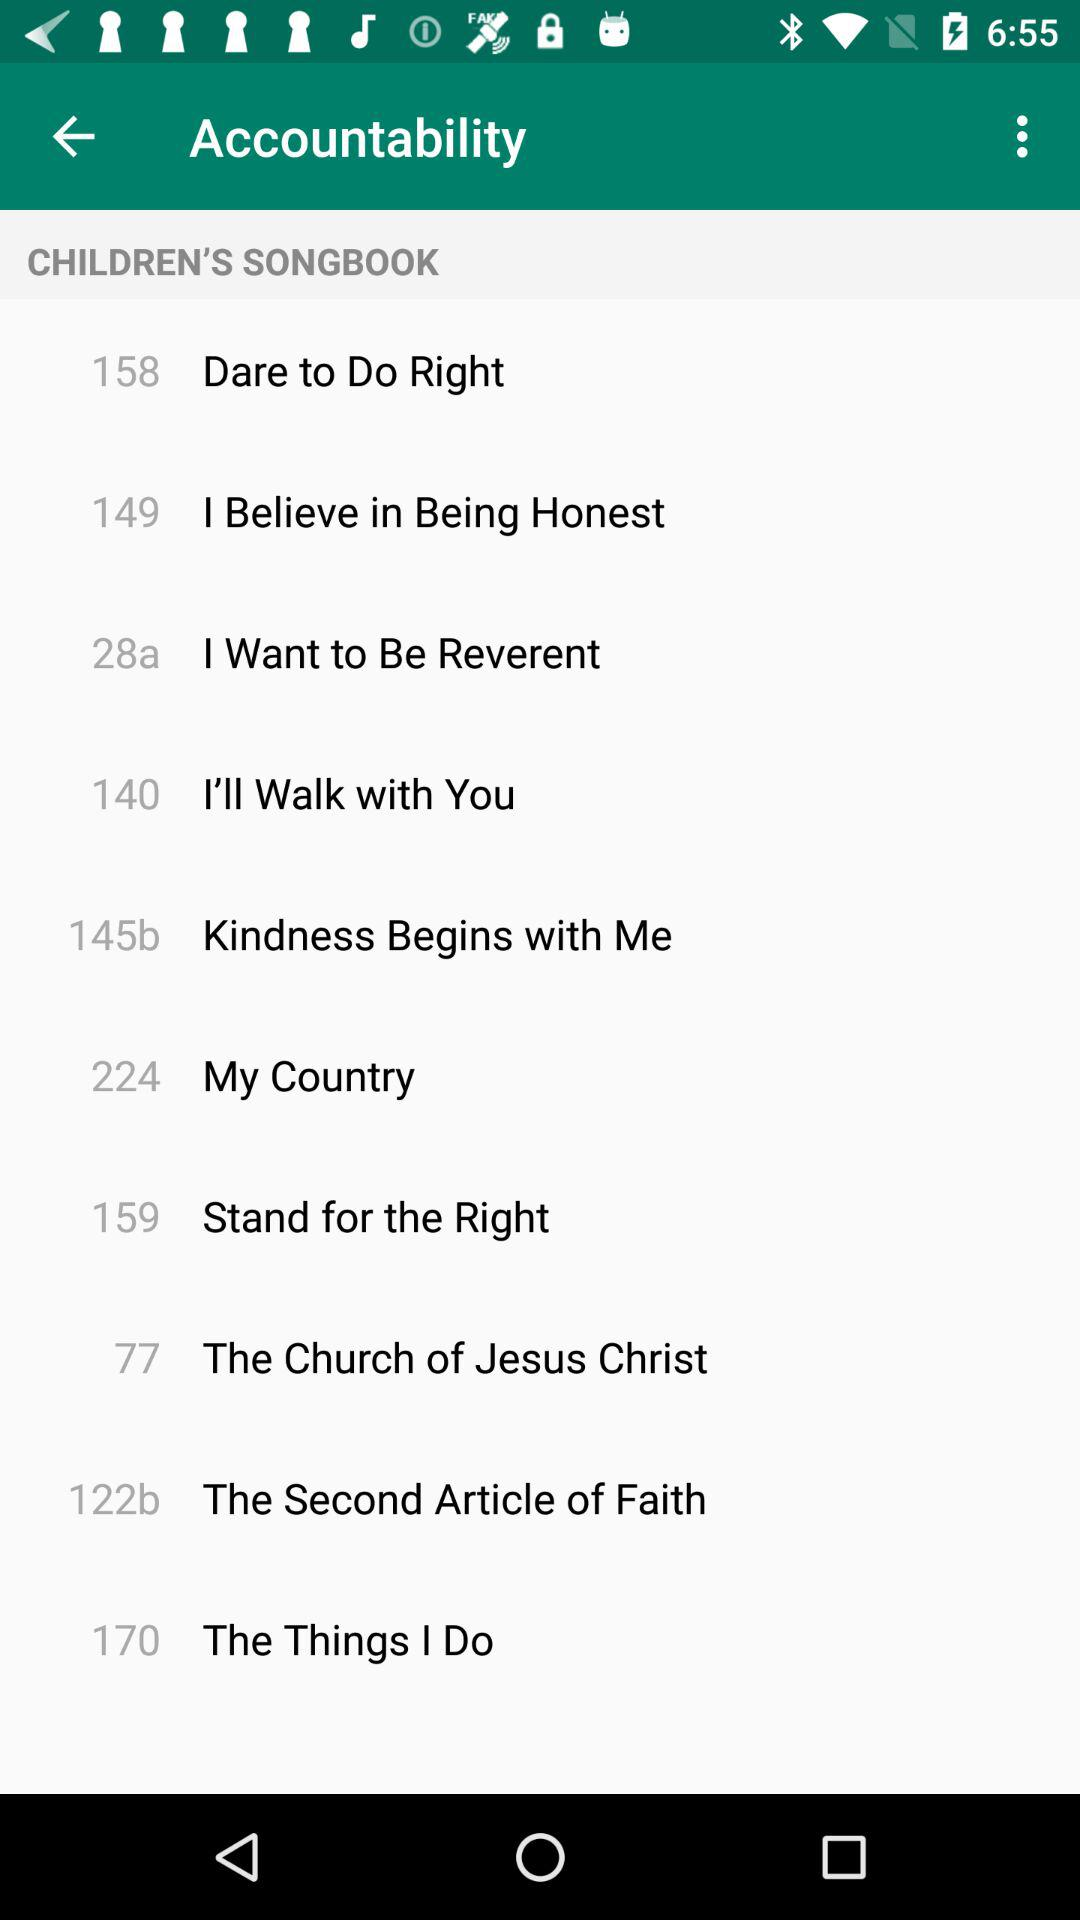How many songbooks are available?
When the provided information is insufficient, respond with <no answer>. <no answer> 